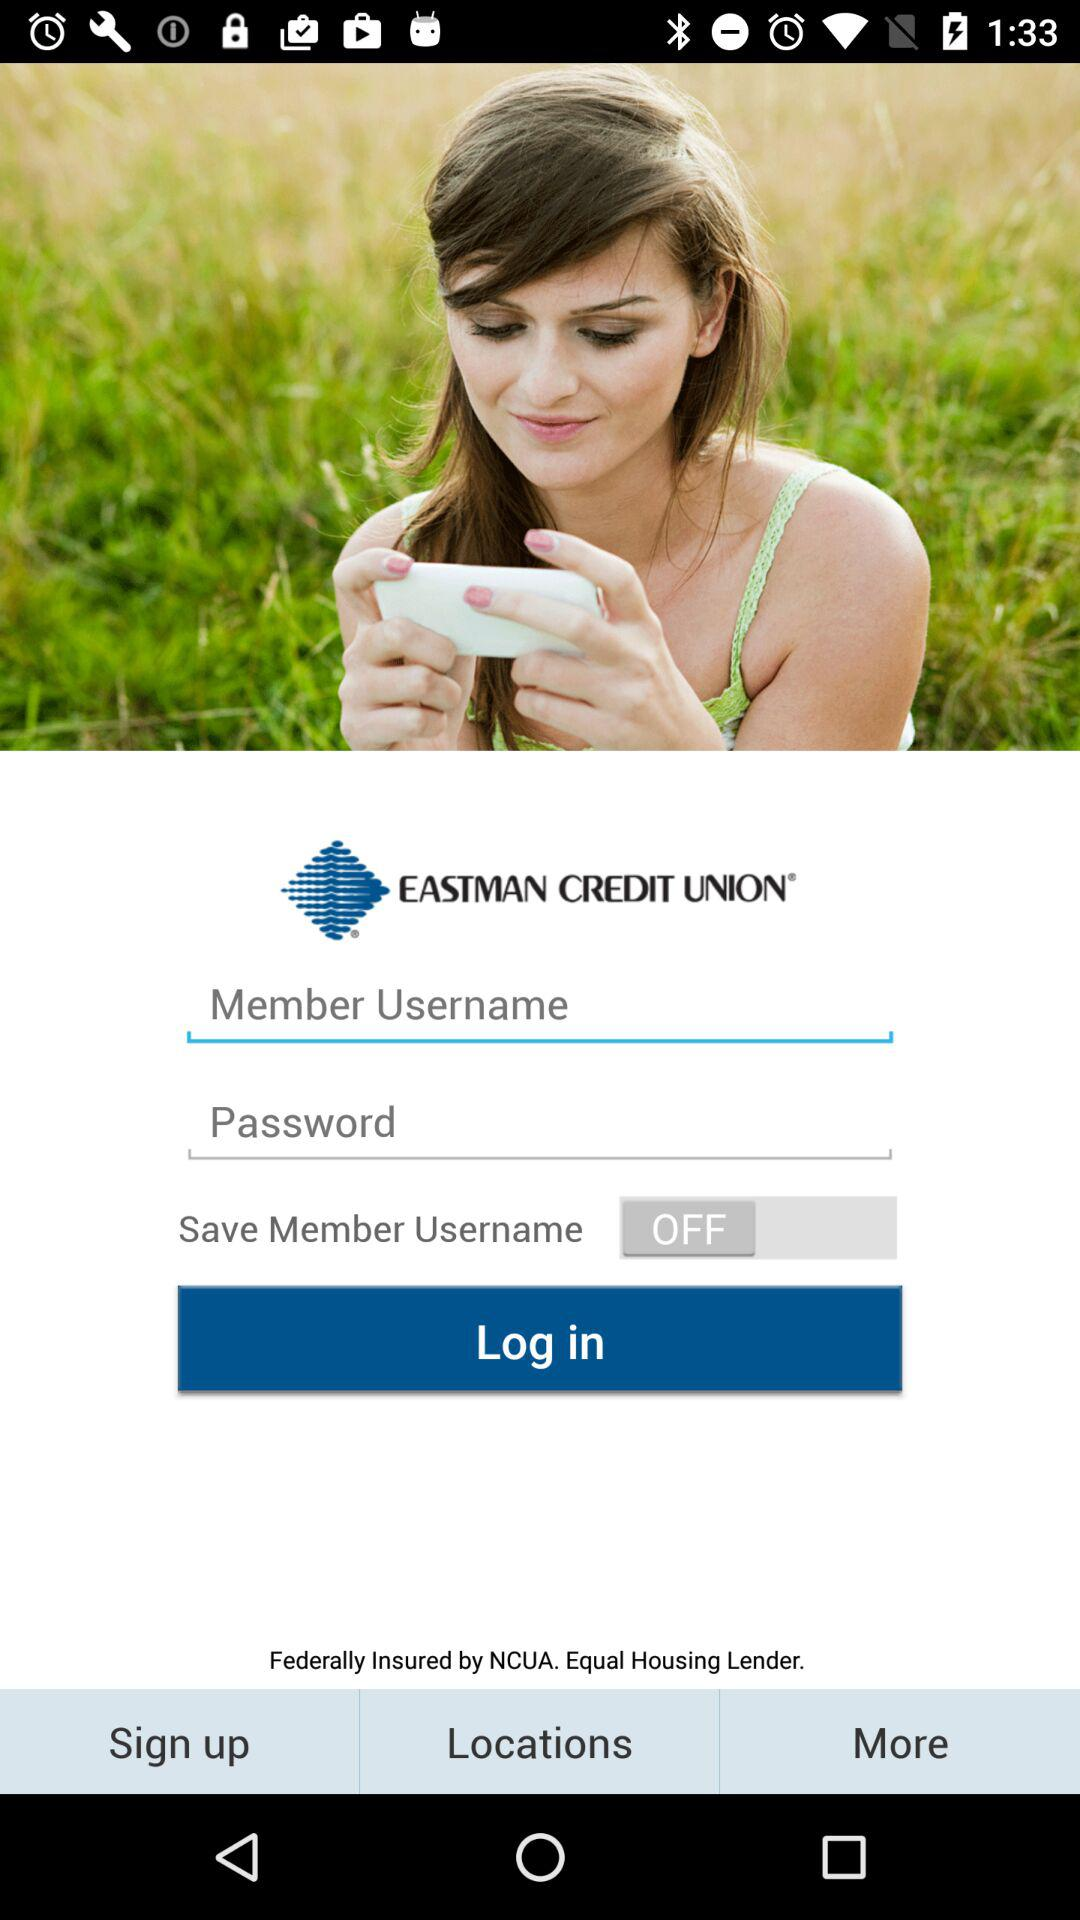What is the application name? The application name is "EASTMAN CREDIT UNION". 